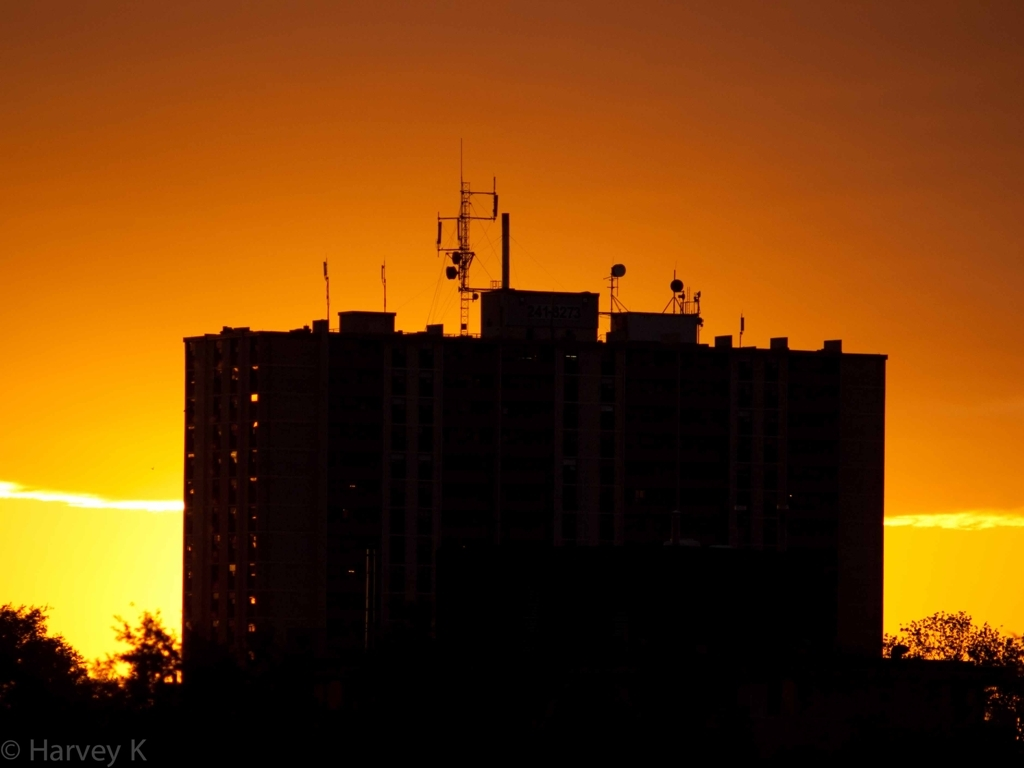What emotions does this image evoke? The image evokes a sense of tranquility and contemplation, the serene sunset and the towering structure's silhouette against the fiery sky may inspire introspection and a feeling of calmness. 